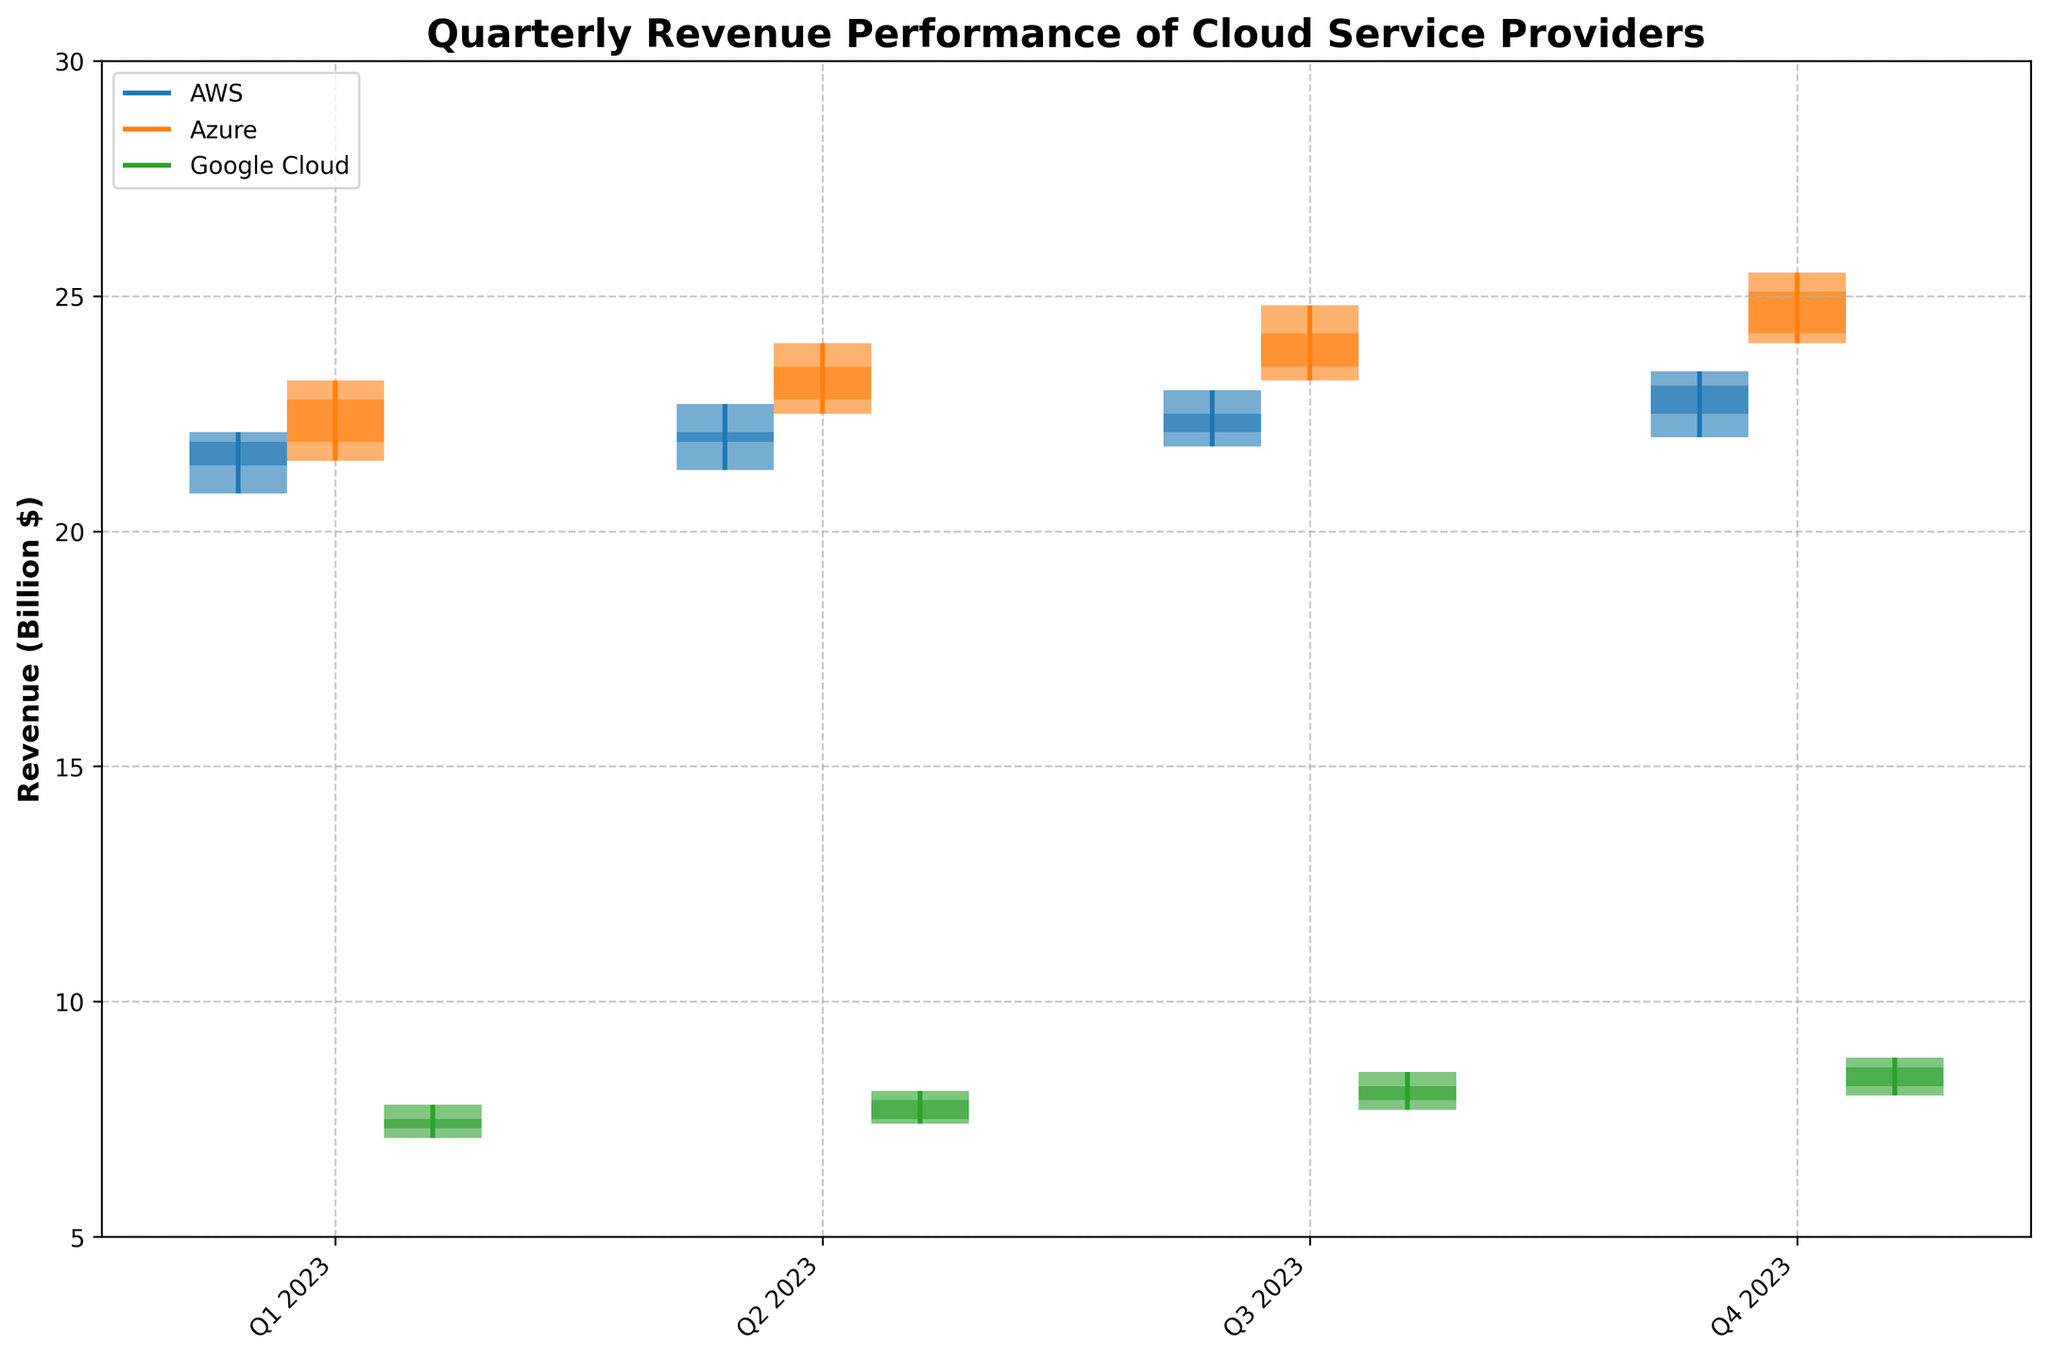What's the title of the figure? The title of the figure is shown at the top center of the plot. It summarizes what the figure is about.
Answer: Quarterly Revenue Performance of Cloud Service Providers What does the y-axis represent? The label on the y-axis indicates the type of data being represented. In this figure, it shows "Revenue (Billion $)".
Answer: Revenue (Billion $) How many providers are being compared in this figure? By looking at the legend or the corresponding groups of bars in different colors, we can see how many providers are included.
Answer: Three Which provider had the highest revenue in Q4 2023? By identifying the provider with the highest "High" value in Q4 2023, you can determine which had the highest revenue.
Answer: Azure What was the revenue range for AWS in Q3 2023? The "High" and "Low" values in the OHLC plot show the revenue range. For AWS in Q3 2023, the range is from 21.8 to 23.0 billion dollars.
Answer: 21.8 to 23.0 billion dollars Which quarter showed the highest revenue growth for Google Cloud? To determine the quarter with the highest revenue growth, compare the "Close" value of each quarter to the "Open" value of the next quarter and identify the largest difference.
Answer: Q4 2023 Compare the overall revenue trend for Azure over the four quarters of 2023. Examine the "Open" and "Close" values for Azure in all quarters to understand the trend. The revenue gradually increases each quarter, from 21.9 billion in Q1 to 25.1 billion in Q4.
Answer: Increasing trend Was there any quarter where AWS had no change in closing revenue compared to the opening of the next quarter? To find this, compare the "Close" value of each quarter with the "Open" value of the subsequent quarter for AWS. For Q2 and Q3, revenue closes at 22.1 and opens at the same 22.1 billion in Q3.
Answer: Q2 to Q3 